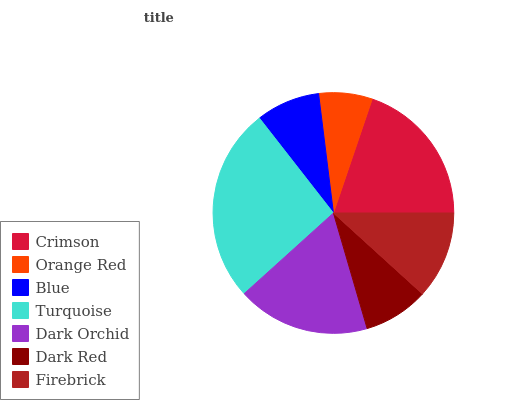Is Orange Red the minimum?
Answer yes or no. Yes. Is Turquoise the maximum?
Answer yes or no. Yes. Is Blue the minimum?
Answer yes or no. No. Is Blue the maximum?
Answer yes or no. No. Is Blue greater than Orange Red?
Answer yes or no. Yes. Is Orange Red less than Blue?
Answer yes or no. Yes. Is Orange Red greater than Blue?
Answer yes or no. No. Is Blue less than Orange Red?
Answer yes or no. No. Is Firebrick the high median?
Answer yes or no. Yes. Is Firebrick the low median?
Answer yes or no. Yes. Is Blue the high median?
Answer yes or no. No. Is Orange Red the low median?
Answer yes or no. No. 